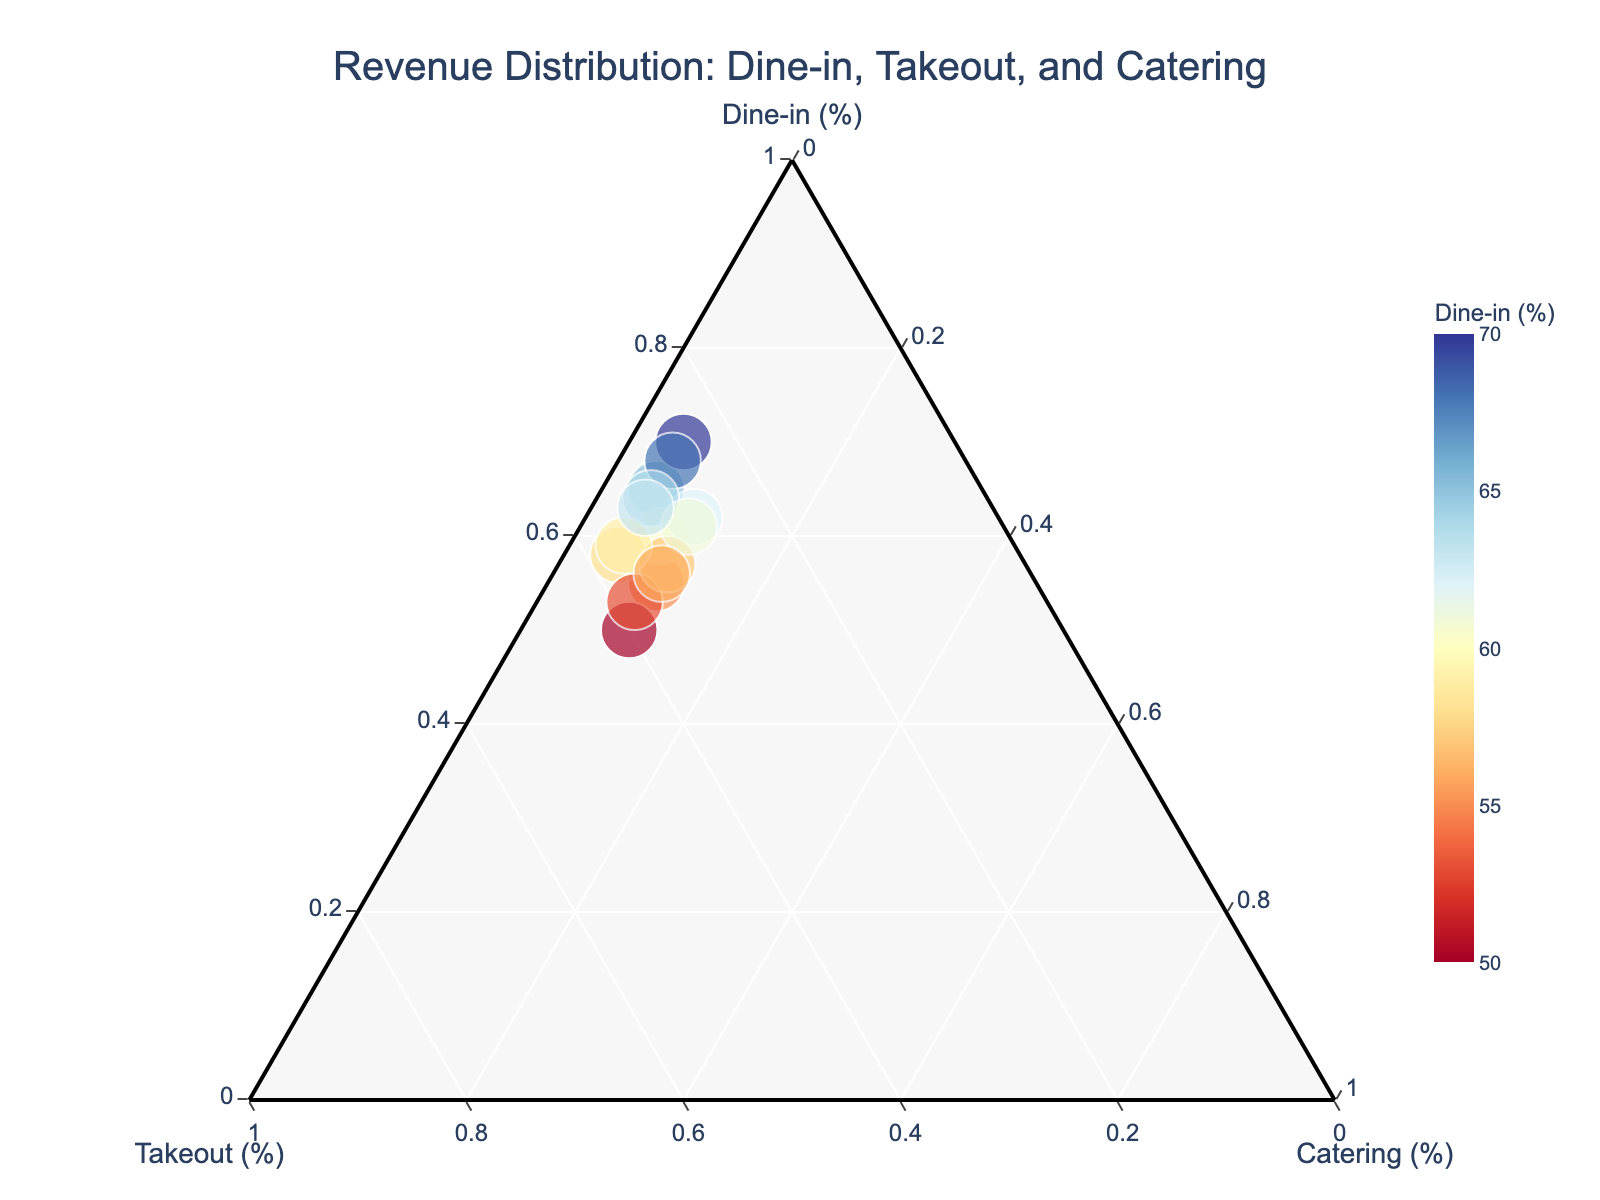What's the title of the plot? The title is typically displayed at the top of the plot to provide a quick summary of what the figure represents. This one is about the revenue distribution of different services.
Answer: Revenue Distribution: Dine-in, Takeout, and Catering How many data points are represented in the plot? There are a certain number of unique data entries, each represented as a separate point in the plot. By counting these points, we can determine the number of data points.
Answer: 15 Which service generates the least revenue on average? To determine which service generates the least revenue on average, we need to average the percentages of Dine-in, Takeout, and Catering for all data points. This involves summing the percentages for each category and dividing by the total number of data points. The smallest average will identify the least generating service.
Answer: Catering Between the highest and lowest Dine-in percentages, what's the range? The highest Dine-in percentage can be found by identifying the maximum value in the Dine-in column, while the lowest can be identified by the minimum value in the same column. The range is the difference between these two values.
Answer: 20 Is there a more dominant service among Dine-in, Takeout, and Catering? By inspecting the plot, we can visually assess whether one service tends to have higher percentages compared to the others. If most points are closer to one apex, that service is more dominant.
Answer: Dine-in What are the values of the data point with the highest Dine-in percentage? In the plot, the data point with the highest Dine-in percentage will be closest to the Dine-in apex. We need to find the exact position of this point, which corresponds to the highest value in the Dine-in column.
Answer: 70, 25, 5 On average, do data points show a balanced distribution among Dine-in, Takeout, and Catering? To answer this, we need to find the average percentage for each of the three services and see if they are relatively close to each other. This involves calculating the averages and comparing their values.
Answer: No, Dine-in is higher If a new data point showed a 60% split for Dine-in and Takeout, what would the percentage for Catering be? Since the total must sum up to 100%, we subtract the given percentages of Dine-in and Takeout from 100 to find the remaining percentage for Catering.
Answer: 40 Which data point has the closest Takeout percentage to the average Takeout percentage? First, calculate the average percentage for Takeout by summing all Takeout values and dividing by the number of data points. Then, find the data point with the Takeout value closest to this average.
Answer: 35 